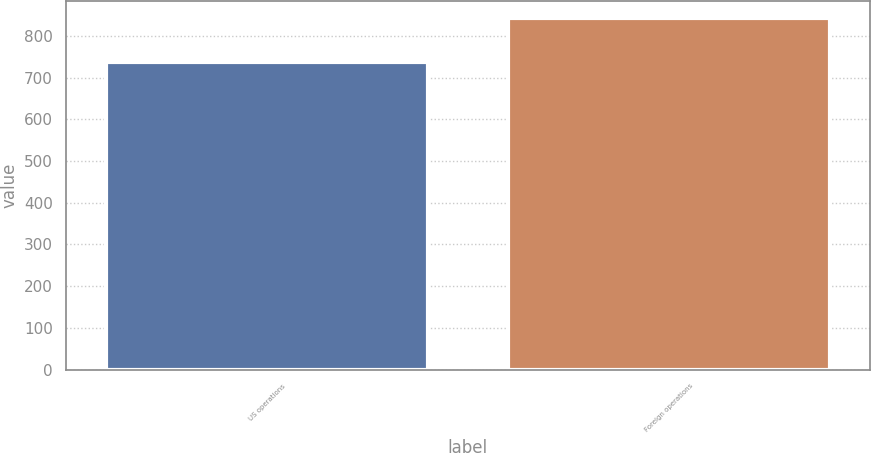Convert chart to OTSL. <chart><loc_0><loc_0><loc_500><loc_500><bar_chart><fcel>US operations<fcel>Foreign operations<nl><fcel>738.1<fcel>842.1<nl></chart> 